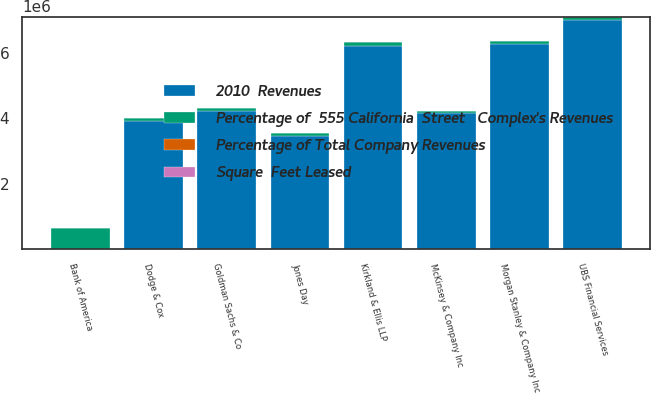<chart> <loc_0><loc_0><loc_500><loc_500><stacked_bar_chart><ecel><fcel>Bank of America<fcel>UBS Financial Services<fcel>Morgan Stanley & Company Inc<fcel>Kirkland & Ellis LLP<fcel>Goldman Sachs & Co<fcel>McKinsey & Company Inc<fcel>Dodge & Cox<fcel>Jones Day<nl><fcel>Percentage of  555 California  Street   Complex's Revenues<fcel>659000<fcel>107000<fcel>89000<fcel>125000<fcel>82000<fcel>54000<fcel>62000<fcel>81000<nl><fcel>2010  Revenues<fcel>34.7<fcel>7.007e+06<fcel>6.289e+06<fcel>6.217e+06<fcel>4.229e+06<fcel>4.171e+06<fcel>3.935e+06<fcel>3.467e+06<nl><fcel>Percentage of Total Company Revenues<fcel>34.7<fcel>6.6<fcel>5.9<fcel>5.9<fcel>4<fcel>3.9<fcel>3.7<fcel>3.3<nl><fcel>Square  Feet Leased<fcel>1.3<fcel>0.3<fcel>0.2<fcel>0.2<fcel>0.2<fcel>0.2<fcel>0.1<fcel>0.1<nl></chart> 